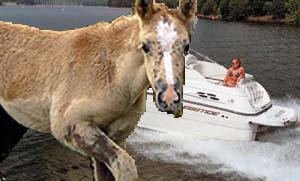How many unicorns are there in the image? 0 